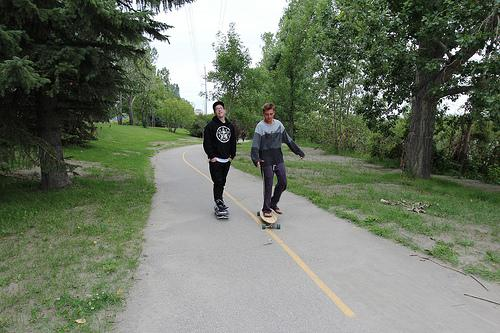Question: who is wearing a star?
Choices:
A. Woman on the left.
B. Man on the right.
C. Man on the left.
D. Child on the right.
Answer with the letter. Answer: C Question: what are they doing?
Choices:
A. Rollerblading.
B. Biking.
C. Skateboarding.
D. Snowboarding.
Answer with the letter. Answer: C Question: how many people are skateboarding?
Choices:
A. 3.
B. 2.
C. 4.
D. 5.
Answer with the letter. Answer: B Question: where are they?
Choices:
A. In a field.
B. In a park.
C. At a playground.
D. At the baseball field.
Answer with the letter. Answer: B 